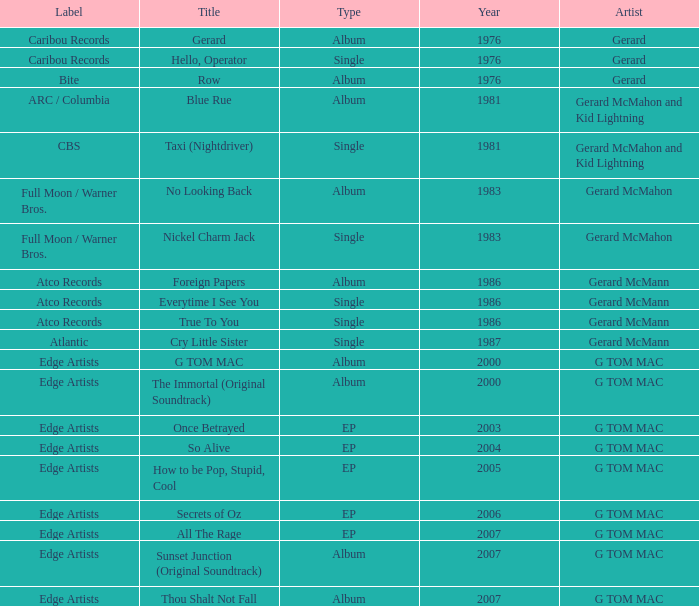Name the Year which has a Label of atco records and a Type of album? Question 2 1986.0. 